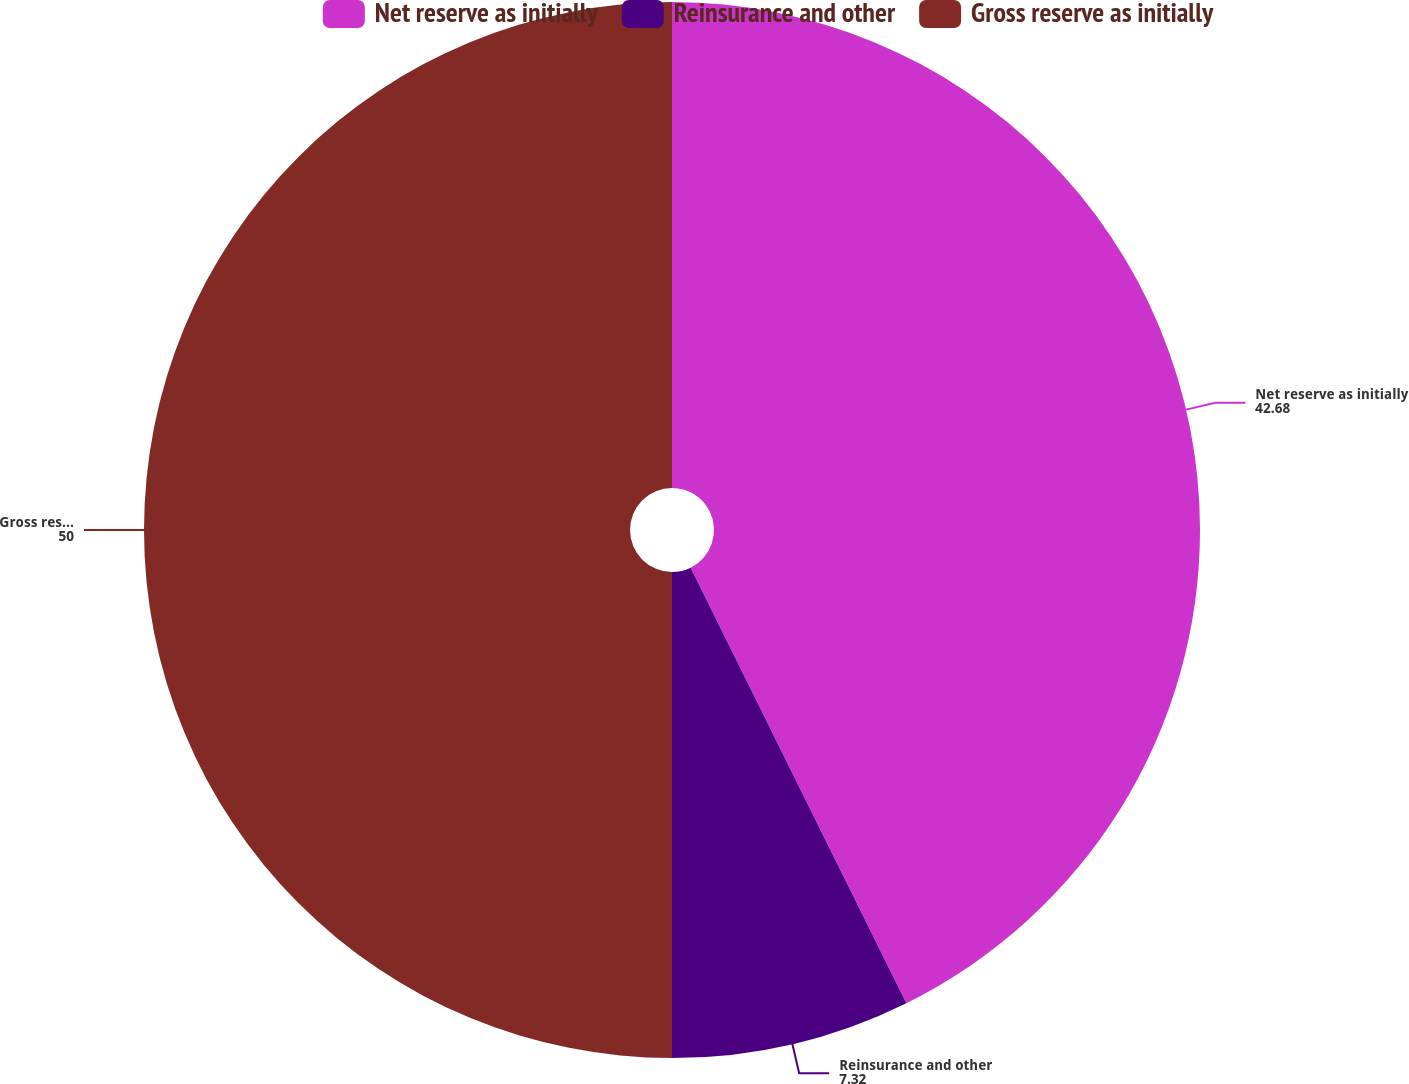Convert chart. <chart><loc_0><loc_0><loc_500><loc_500><pie_chart><fcel>Net reserve as initially<fcel>Reinsurance and other<fcel>Gross reserve as initially<nl><fcel>42.68%<fcel>7.32%<fcel>50.0%<nl></chart> 